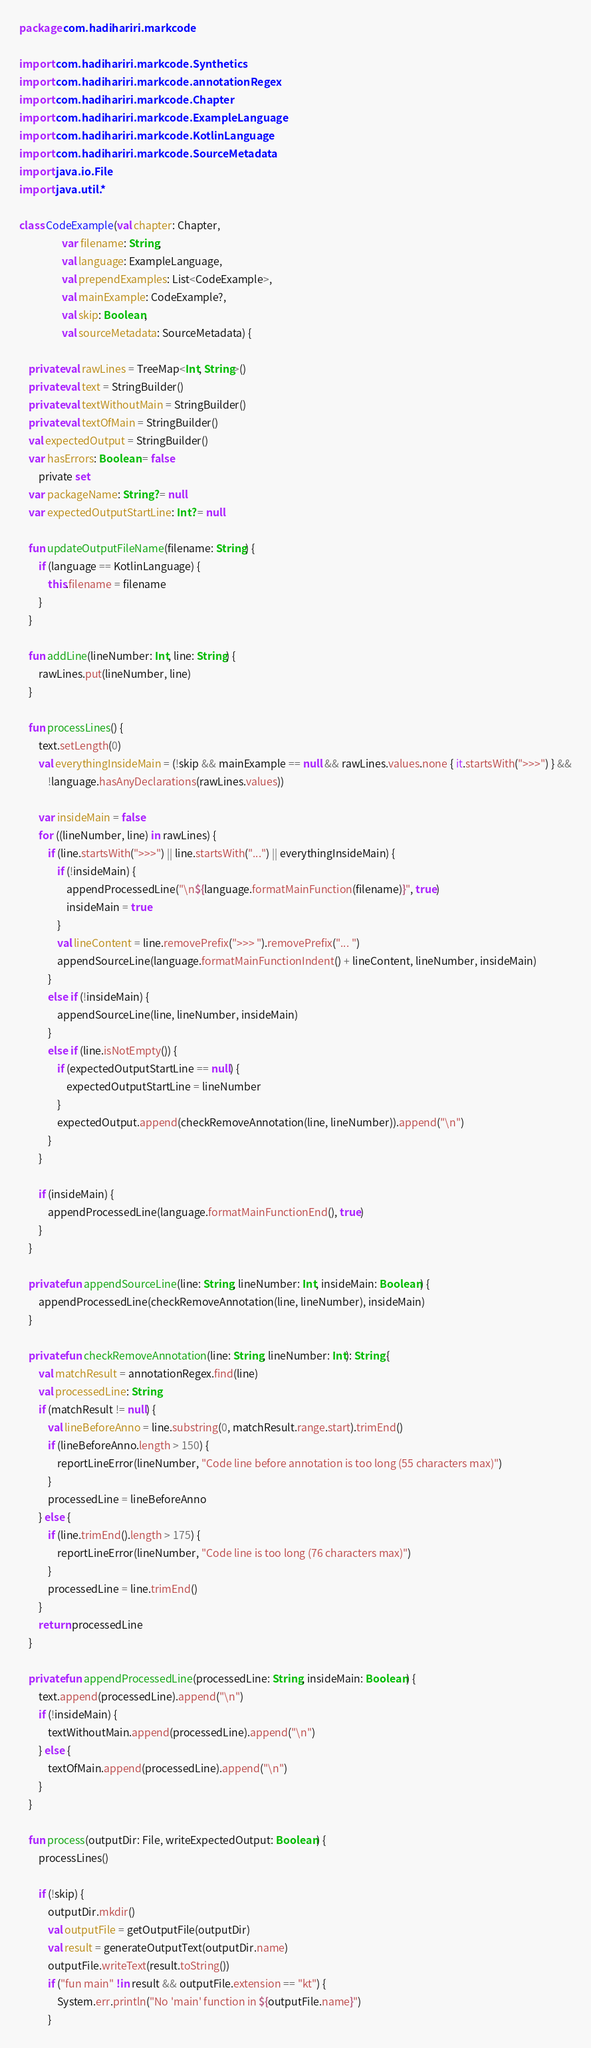<code> <loc_0><loc_0><loc_500><loc_500><_Kotlin_>package com.hadihariri.markcode

import com.hadihariri.markcode.Synthetics
import com.hadihariri.markcode.annotationRegex
import com.hadihariri.markcode.Chapter
import com.hadihariri.markcode.ExampleLanguage
import com.hadihariri.markcode.KotlinLanguage
import com.hadihariri.markcode.SourceMetadata
import java.io.File
import java.util.*

class CodeExample(val chapter: Chapter,
                  var filename: String,
                  val language: ExampleLanguage,
                  val prependExamples: List<CodeExample>,
                  val mainExample: CodeExample?,
                  val skip: Boolean,
                  val sourceMetadata: SourceMetadata) {

    private val rawLines = TreeMap<Int, String>()
    private val text = StringBuilder()
    private val textWithoutMain = StringBuilder()
    private val textOfMain = StringBuilder()
    val expectedOutput = StringBuilder()
    var hasErrors: Boolean = false
        private set
    var packageName: String? = null
    var expectedOutputStartLine: Int? = null

    fun updateOutputFileName(filename: String) {
        if (language == KotlinLanguage) {
            this.filename = filename
        }
    }

    fun addLine(lineNumber: Int, line: String) {
        rawLines.put(lineNumber, line)
    }

    fun processLines() {
        text.setLength(0)
        val everythingInsideMain = (!skip && mainExample == null && rawLines.values.none { it.startsWith(">>>") } &&
            !language.hasAnyDeclarations(rawLines.values))

        var insideMain = false
        for ((lineNumber, line) in rawLines) {
            if (line.startsWith(">>>") || line.startsWith("...") || everythingInsideMain) {
                if (!insideMain) {
                    appendProcessedLine("\n${language.formatMainFunction(filename)}", true)
                    insideMain = true
                }
                val lineContent = line.removePrefix(">>> ").removePrefix("... ")
                appendSourceLine(language.formatMainFunctionIndent() + lineContent, lineNumber, insideMain)
            }
            else if (!insideMain) {
                appendSourceLine(line, lineNumber, insideMain)
            }
            else if (line.isNotEmpty()) {
                if (expectedOutputStartLine == null) {
                    expectedOutputStartLine = lineNumber
                }
                expectedOutput.append(checkRemoveAnnotation(line, lineNumber)).append("\n")
            }
        }

        if (insideMain) {
            appendProcessedLine(language.formatMainFunctionEnd(), true)
        }
    }

    private fun appendSourceLine(line: String, lineNumber: Int, insideMain: Boolean) {
        appendProcessedLine(checkRemoveAnnotation(line, lineNumber), insideMain)
    }

    private fun checkRemoveAnnotation(line: String, lineNumber: Int): String {
        val matchResult = annotationRegex.find(line)
        val processedLine: String
        if (matchResult != null) {
            val lineBeforeAnno = line.substring(0, matchResult.range.start).trimEnd()
            if (lineBeforeAnno.length > 150) {
                reportLineError(lineNumber, "Code line before annotation is too long (55 characters max)")
            }
            processedLine = lineBeforeAnno
        } else {
            if (line.trimEnd().length > 175) {
                reportLineError(lineNumber, "Code line is too long (76 characters max)")
            }
            processedLine = line.trimEnd()
        }
        return processedLine
    }

    private fun appendProcessedLine(processedLine: String, insideMain: Boolean) {
        text.append(processedLine).append("\n")
        if (!insideMain) {
            textWithoutMain.append(processedLine).append("\n")
        } else {
            textOfMain.append(processedLine).append("\n")
        }
    }

    fun process(outputDir: File, writeExpectedOutput: Boolean) {
        processLines()

        if (!skip) {
            outputDir.mkdir()
            val outputFile = getOutputFile(outputDir)
            val result = generateOutputText(outputDir.name)
            outputFile.writeText(result.toString())
            if ("fun main" !in result && outputFile.extension == "kt") {
                System.err.println("No 'main' function in ${outputFile.name}")
            }
</code> 